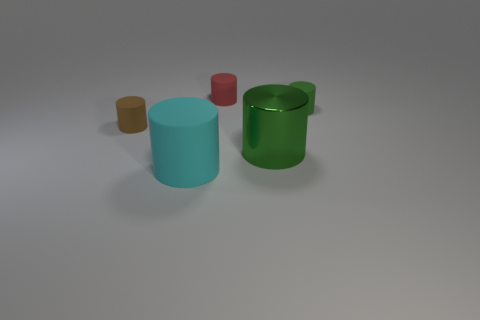Subtract all red cylinders. How many cylinders are left? 4 Subtract 1 cylinders. How many cylinders are left? 4 Subtract all cyan rubber cylinders. How many cylinders are left? 4 Subtract all gray cylinders. Subtract all red blocks. How many cylinders are left? 5 Add 4 small cyan objects. How many objects exist? 9 Add 2 small green matte cylinders. How many small green matte cylinders exist? 3 Subtract 0 green cubes. How many objects are left? 5 Subtract all large green shiny things. Subtract all big cyan things. How many objects are left? 3 Add 5 large cylinders. How many large cylinders are left? 7 